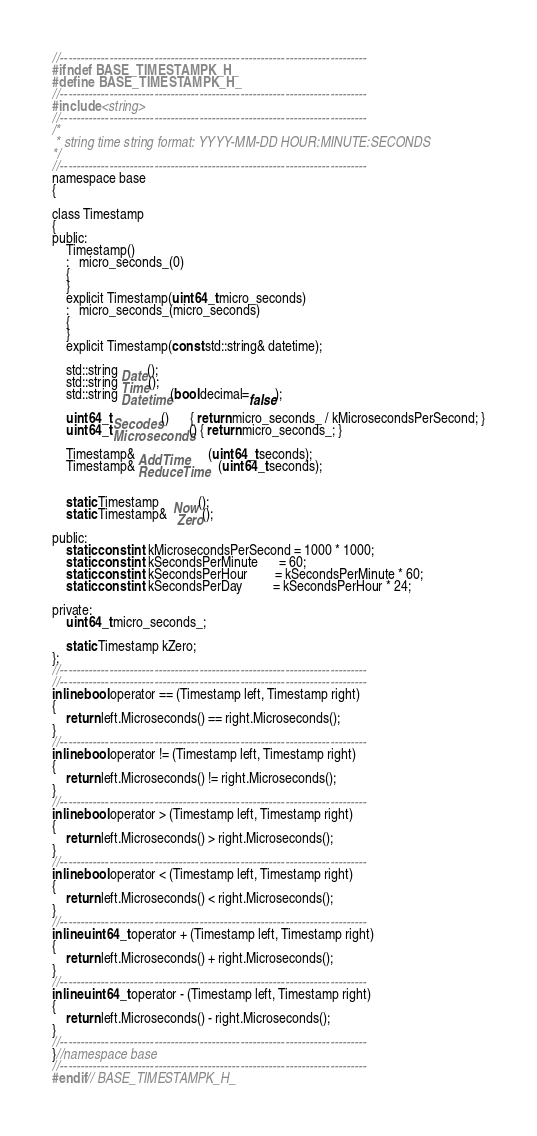<code> <loc_0><loc_0><loc_500><loc_500><_C_>//---------------------------------------------------------------------------
#ifndef BASE_TIMESTAMPK_H_
#define BASE_TIMESTAMPK_H_
//---------------------------------------------------------------------------
#include <string>
//---------------------------------------------------------------------------
/*
 * string time string format: YYYY-MM-DD HOUR:MINUTE:SECONDS
*/
//---------------------------------------------------------------------------
namespace base
{

class Timestamp
{
public:
    Timestamp()
    :   micro_seconds_(0)
    {
    }
    explicit Timestamp(uint64_t micro_seconds)
    :   micro_seconds_(micro_seconds)
    {
    }
    explicit Timestamp(const std::string& datetime);

    std::string Date();
    std::string Time();
    std::string Datetime(bool decimal=false);

    uint64_t Secodes()      { return micro_seconds_ / kMicrosecondsPerSecond; }
    uint64_t Microseconds() { return micro_seconds_; }

    Timestamp& AddTime      (uint64_t seconds);
    Timestamp& ReduceTime   (uint64_t seconds);


    static Timestamp    Now();
    static Timestamp&   Zero();

public:
    static const int kMicrosecondsPerSecond = 1000 * 1000;
    static const int kSecondsPerMinute      = 60;
    static const int kSecondsPerHour        = kSecondsPerMinute * 60;
    static const int kSecondsPerDay         = kSecondsPerHour * 24;

private:
    uint64_t micro_seconds_;

    static Timestamp kZero;
};
//---------------------------------------------------------------------------
//---------------------------------------------------------------------------
inline bool operator == (Timestamp left, Timestamp right)
{
    return left.Microseconds() == right.Microseconds();
}
//---------------------------------------------------------------------------
inline bool operator != (Timestamp left, Timestamp right)
{
    return left.Microseconds() != right.Microseconds();
}
//---------------------------------------------------------------------------
inline bool operator > (Timestamp left, Timestamp right)
{
    return left.Microseconds() > right.Microseconds();
}
//---------------------------------------------------------------------------
inline bool operator < (Timestamp left, Timestamp right)
{
    return left.Microseconds() < right.Microseconds();
}
//---------------------------------------------------------------------------
inline uint64_t operator + (Timestamp left, Timestamp right)
{
    return left.Microseconds() + right.Microseconds();
}
//---------------------------------------------------------------------------
inline uint64_t operator - (Timestamp left, Timestamp right)
{
    return left.Microseconds() - right.Microseconds();
}
//---------------------------------------------------------------------------
}//namespace base
//---------------------------------------------------------------------------
#endif// BASE_TIMESTAMPK_H_
</code> 